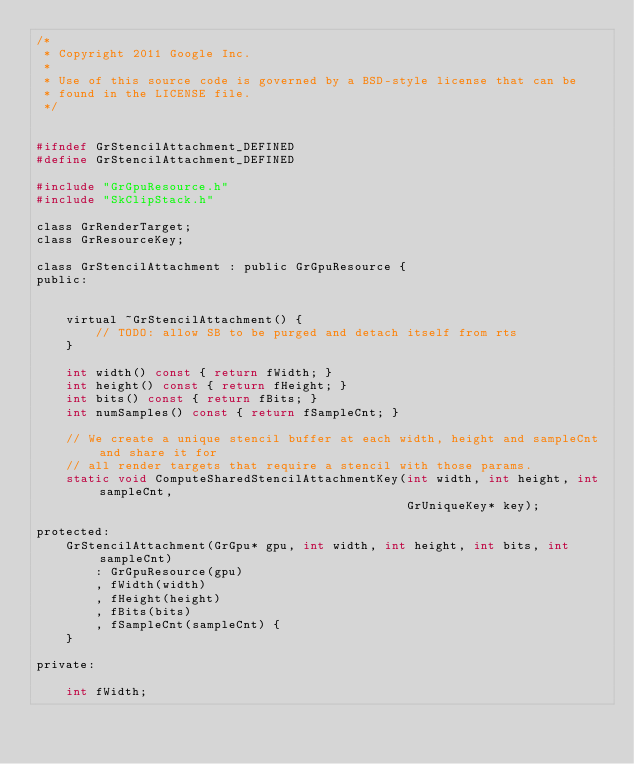Convert code to text. <code><loc_0><loc_0><loc_500><loc_500><_C_>/*
 * Copyright 2011 Google Inc.
 *
 * Use of this source code is governed by a BSD-style license that can be
 * found in the LICENSE file.
 */


#ifndef GrStencilAttachment_DEFINED
#define GrStencilAttachment_DEFINED

#include "GrGpuResource.h"
#include "SkClipStack.h"

class GrRenderTarget;
class GrResourceKey;

class GrStencilAttachment : public GrGpuResource {
public:


    virtual ~GrStencilAttachment() {
        // TODO: allow SB to be purged and detach itself from rts
    }

    int width() const { return fWidth; }
    int height() const { return fHeight; }
    int bits() const { return fBits; }
    int numSamples() const { return fSampleCnt; }

    // We create a unique stencil buffer at each width, height and sampleCnt and share it for
    // all render targets that require a stencil with those params.
    static void ComputeSharedStencilAttachmentKey(int width, int height, int sampleCnt,
                                                  GrUniqueKey* key);

protected:
    GrStencilAttachment(GrGpu* gpu, int width, int height, int bits, int sampleCnt)
        : GrGpuResource(gpu)
        , fWidth(width)
        , fHeight(height)
        , fBits(bits)
        , fSampleCnt(sampleCnt) {
    }

private:

    int fWidth;</code> 